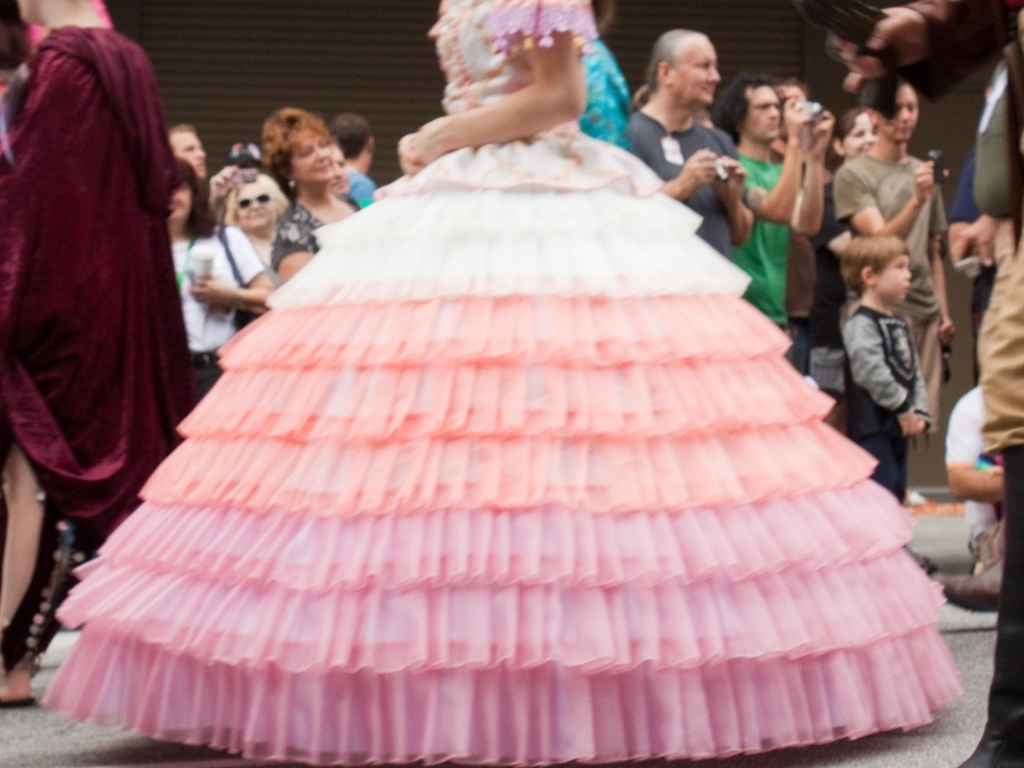How does the image quality affect the viewer's perception of the scene? The image's lack of clarity due to its blurred nature can evoke a sense of movement, dynamism, or even chaos, which may be fitting for a lively event like a parade. However, it also makes it difficult to discern finer details, which could lead to a loss of context and reduce the viewer's ability to fully connect with the specific moments and emotions of the scene. 